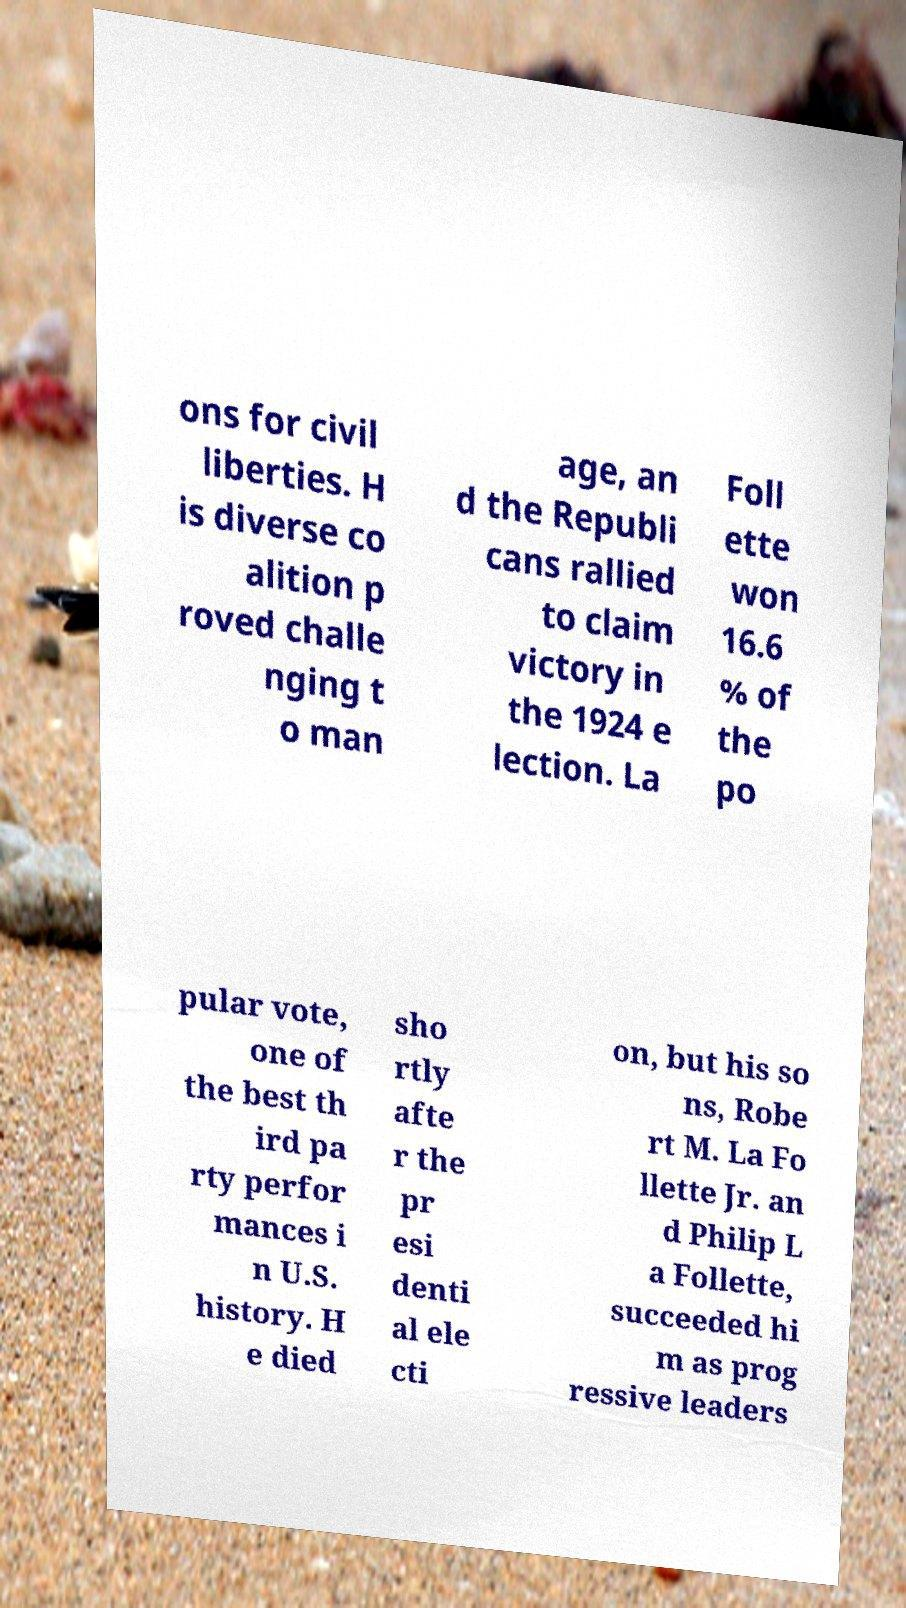For documentation purposes, I need the text within this image transcribed. Could you provide that? ons for civil liberties. H is diverse co alition p roved challe nging t o man age, an d the Republi cans rallied to claim victory in the 1924 e lection. La Foll ette won 16.6 % of the po pular vote, one of the best th ird pa rty perfor mances i n U.S. history. H e died sho rtly afte r the pr esi denti al ele cti on, but his so ns, Robe rt M. La Fo llette Jr. an d Philip L a Follette, succeeded hi m as prog ressive leaders 